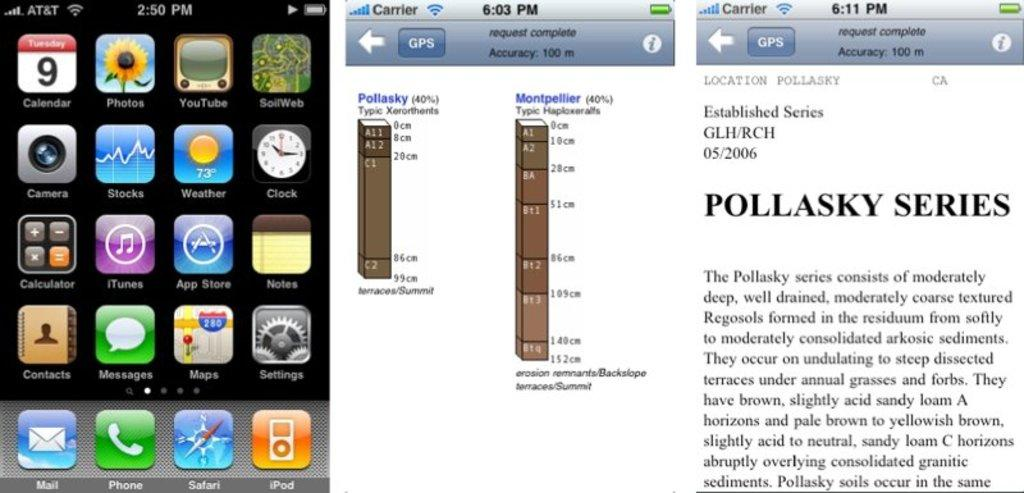Provide a one-sentence caption for the provided image. The date shown on the phone is Tuesday the ninth. 